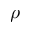<formula> <loc_0><loc_0><loc_500><loc_500>\rho</formula> 